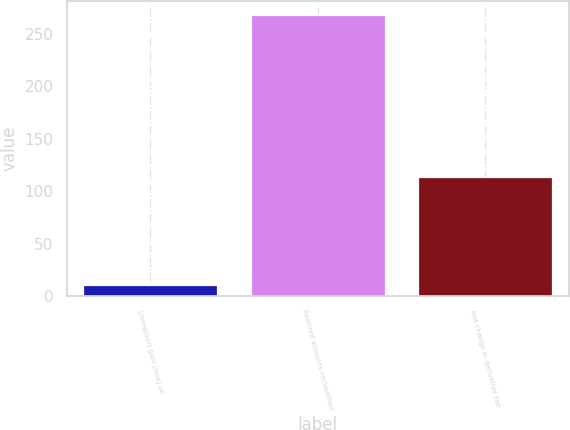Convert chart to OTSL. <chart><loc_0><loc_0><loc_500><loc_500><bar_chart><fcel>Unrealized gain (loss) on<fcel>Realized amounts reclassified<fcel>Net change in derivative fair<nl><fcel>10<fcel>268<fcel>113<nl></chart> 